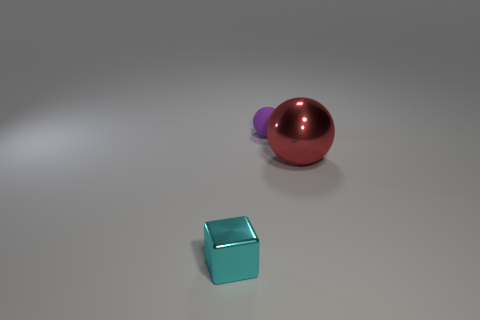Add 3 cyan objects. How many objects exist? 6 Subtract all spheres. How many objects are left? 1 Subtract 0 red cylinders. How many objects are left? 3 Subtract all cyan cubes. Subtract all cyan metallic things. How many objects are left? 1 Add 2 purple objects. How many purple objects are left? 3 Add 2 big brown matte balls. How many big brown matte balls exist? 2 